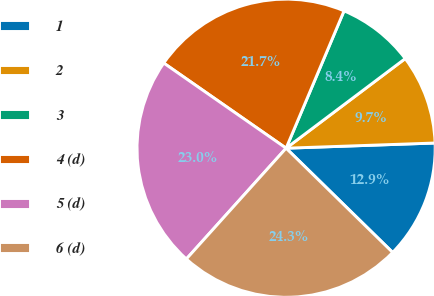Convert chart. <chart><loc_0><loc_0><loc_500><loc_500><pie_chart><fcel>1<fcel>2<fcel>3<fcel>4 (d)<fcel>5 (d)<fcel>6 (d)<nl><fcel>12.88%<fcel>9.71%<fcel>8.38%<fcel>21.68%<fcel>23.01%<fcel>24.34%<nl></chart> 